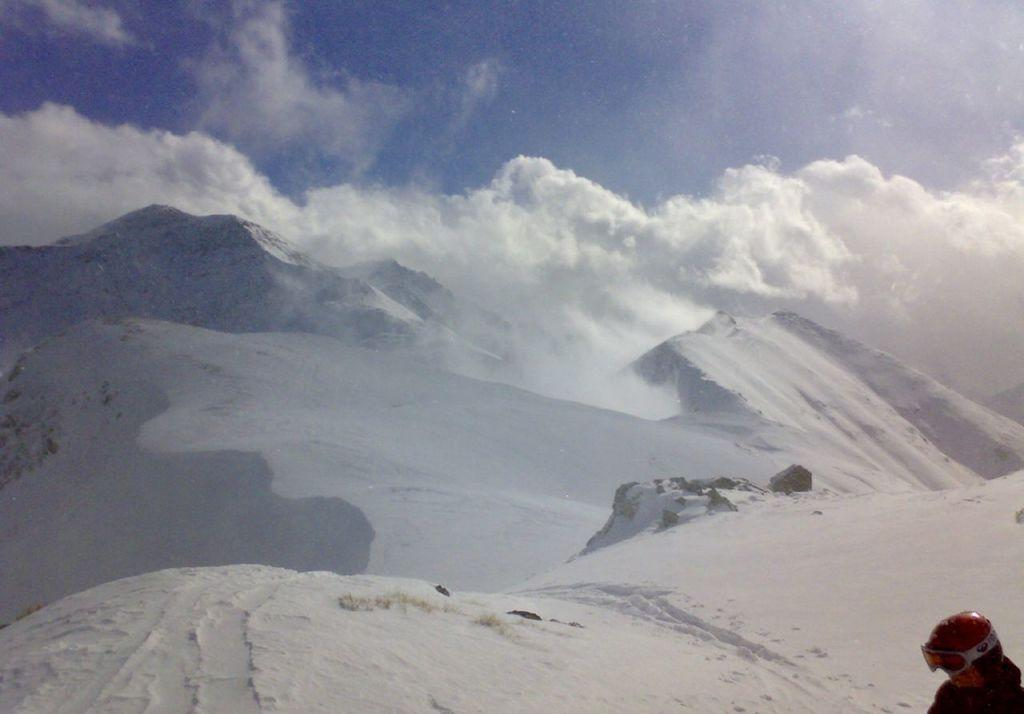What type of natural formation can be seen in the image? There are snow mountains in the image. What part of the environment is visible in the background of the image? The sky is visible in the background of the image. Can you describe the person in the image? There is a person wearing a helmet in the image. What type of beast can be seen roaming on the roof in the image? There is no beast or roof present in the image; it features snow mountains and a person wearing a helmet. 